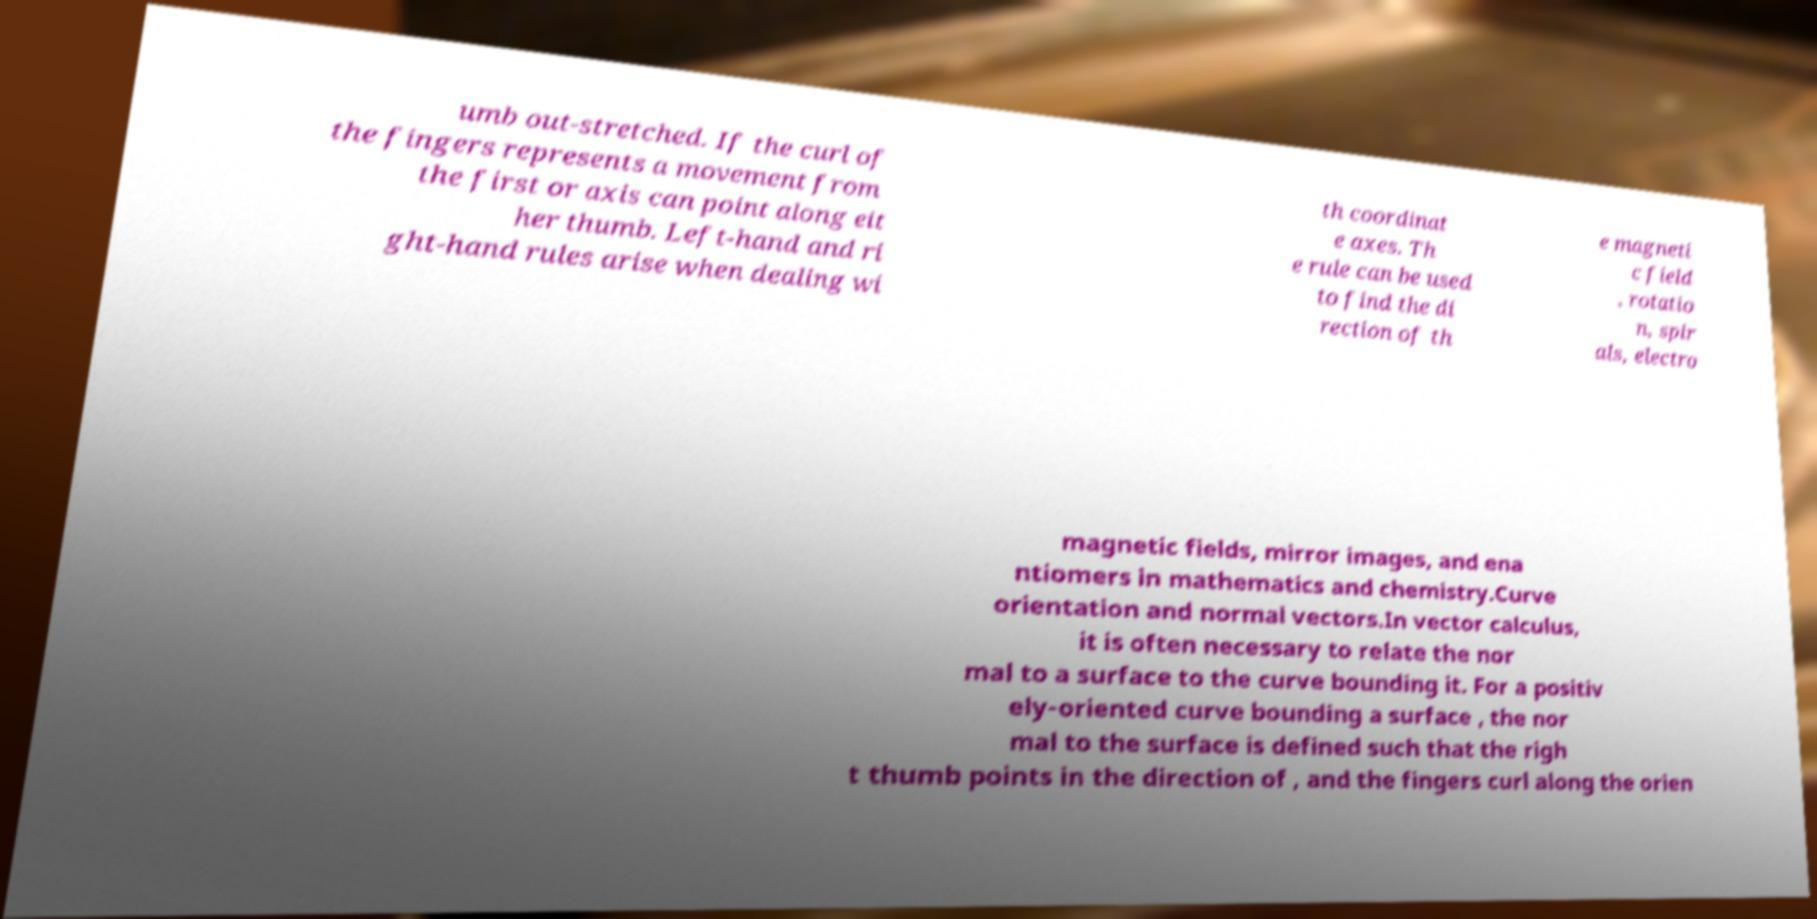For documentation purposes, I need the text within this image transcribed. Could you provide that? umb out-stretched. If the curl of the fingers represents a movement from the first or axis can point along eit her thumb. Left-hand and ri ght-hand rules arise when dealing wi th coordinat e axes. Th e rule can be used to find the di rection of th e magneti c field , rotatio n, spir als, electro magnetic fields, mirror images, and ena ntiomers in mathematics and chemistry.Curve orientation and normal vectors.In vector calculus, it is often necessary to relate the nor mal to a surface to the curve bounding it. For a positiv ely-oriented curve bounding a surface , the nor mal to the surface is defined such that the righ t thumb points in the direction of , and the fingers curl along the orien 